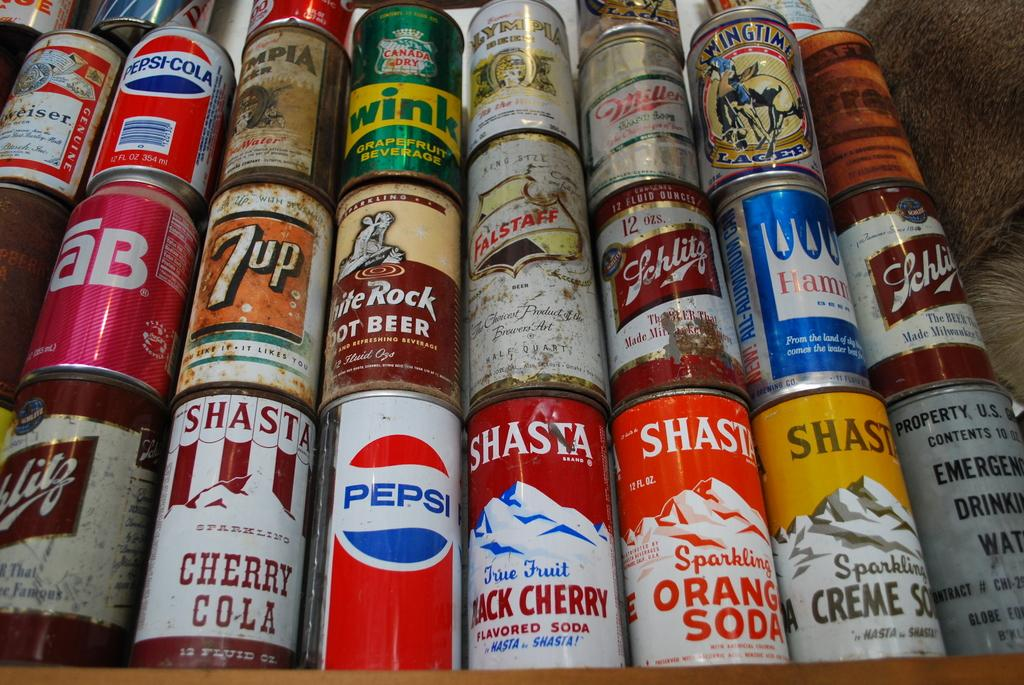Provide a one-sentence caption for the provided image. Soda Cans stacked with different companies labeled on them; example is a Pepsi Can. 